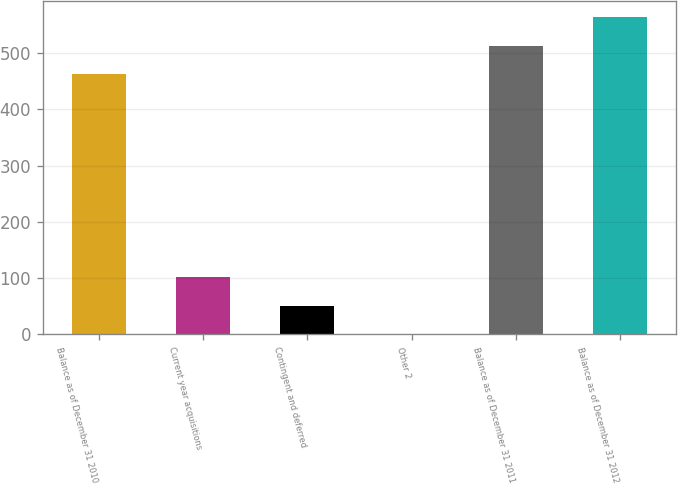Convert chart to OTSL. <chart><loc_0><loc_0><loc_500><loc_500><bar_chart><fcel>Balance as of December 31 2010<fcel>Current year acquisitions<fcel>Contingent and deferred<fcel>Other 2<fcel>Balance as of December 31 2011<fcel>Balance as of December 31 2012<nl><fcel>462.5<fcel>101.6<fcel>51.05<fcel>0.5<fcel>513.05<fcel>563.6<nl></chart> 